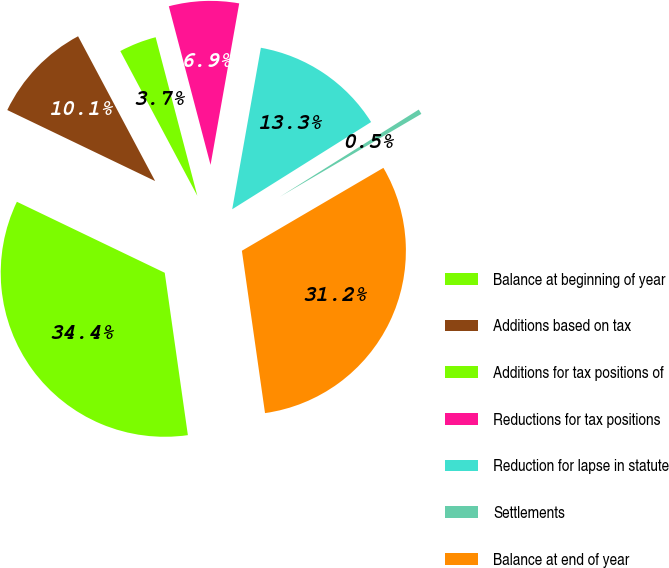<chart> <loc_0><loc_0><loc_500><loc_500><pie_chart><fcel>Balance at beginning of year<fcel>Additions based on tax<fcel>Additions for tax positions of<fcel>Reductions for tax positions<fcel>Reduction for lapse in statute<fcel>Settlements<fcel>Balance at end of year<nl><fcel>34.38%<fcel>10.09%<fcel>3.69%<fcel>6.89%<fcel>13.28%<fcel>0.49%<fcel>31.18%<nl></chart> 